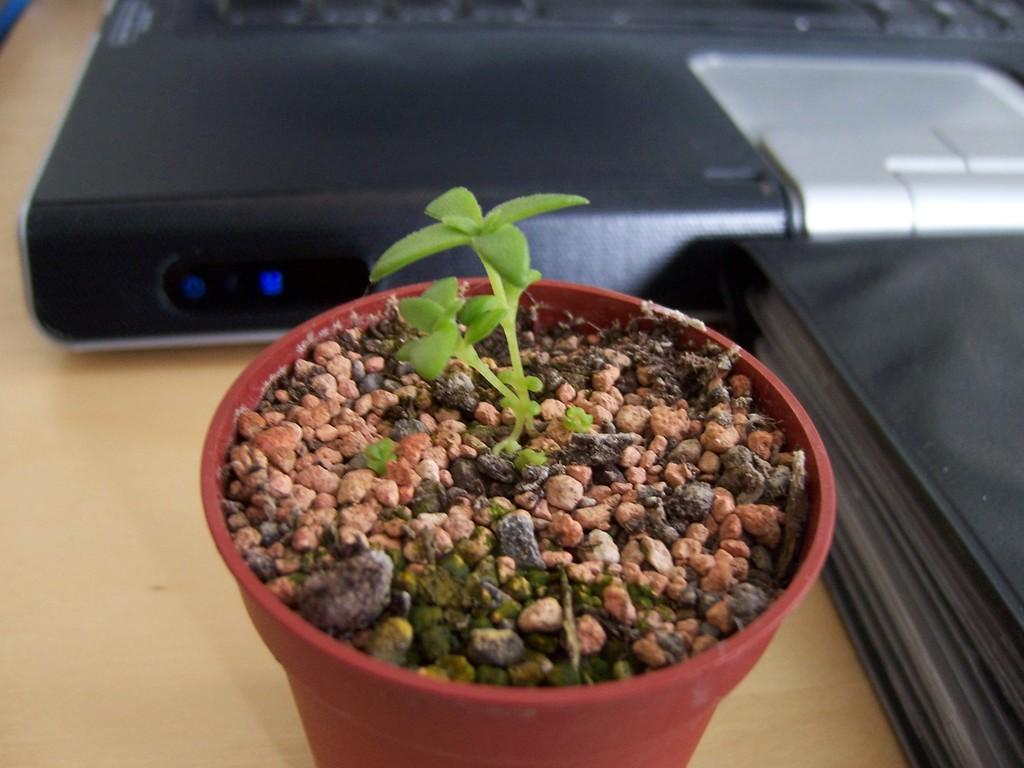What type of living organism can be seen in the image? There is a plant in the image. What can be seen at the top of the image? There is electrical equipment at the top of the image. What is located on the right side of the image? There is a file on the right side of the image. What type of vegetable is being cooked on the stove in the image? There is no stove or vegetable present in the image. 